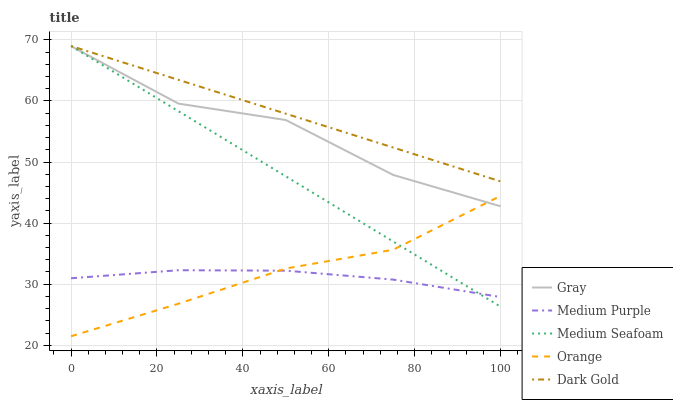Does Medium Purple have the minimum area under the curve?
Answer yes or no. Yes. Does Dark Gold have the maximum area under the curve?
Answer yes or no. Yes. Does Gray have the minimum area under the curve?
Answer yes or no. No. Does Gray have the maximum area under the curve?
Answer yes or no. No. Is Medium Seafoam the smoothest?
Answer yes or no. Yes. Is Gray the roughest?
Answer yes or no. Yes. Is Orange the smoothest?
Answer yes or no. No. Is Orange the roughest?
Answer yes or no. No. Does Orange have the lowest value?
Answer yes or no. Yes. Does Gray have the lowest value?
Answer yes or no. No. Does Dark Gold have the highest value?
Answer yes or no. Yes. Does Gray have the highest value?
Answer yes or no. No. Is Orange less than Dark Gold?
Answer yes or no. Yes. Is Gray greater than Medium Purple?
Answer yes or no. Yes. Does Orange intersect Gray?
Answer yes or no. Yes. Is Orange less than Gray?
Answer yes or no. No. Is Orange greater than Gray?
Answer yes or no. No. Does Orange intersect Dark Gold?
Answer yes or no. No. 